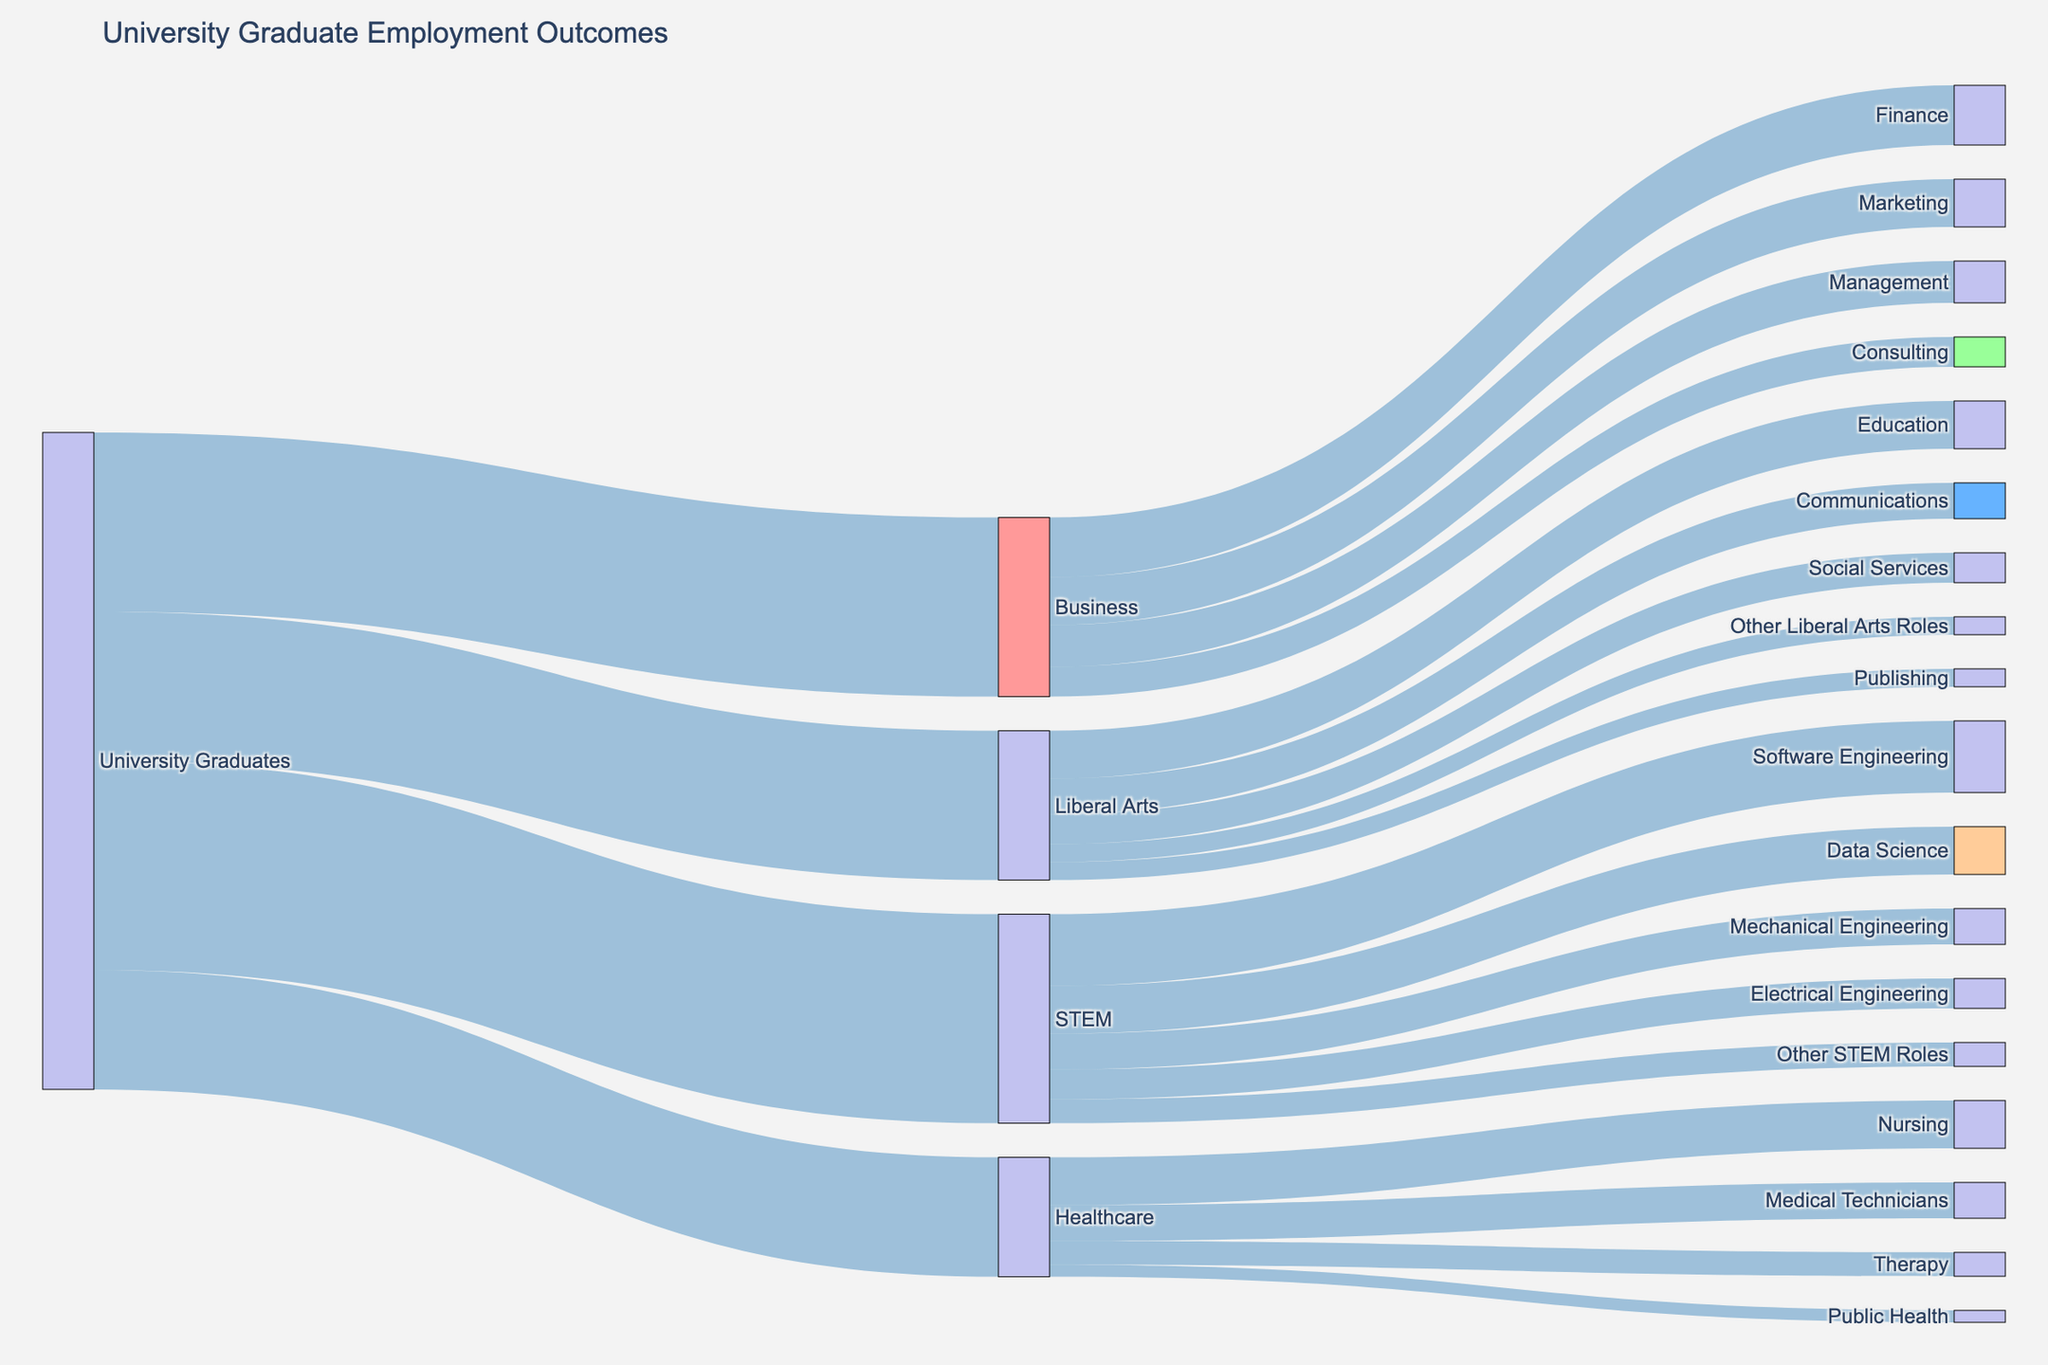What is the title of the figure? The title is typically found at the top of the figure. In this case, it is clearly labeled in the layout settings.
Answer: University Graduate Employment Outcomes What industry do the most University Graduates go into? By observing the height or size of the flows from "University Graduates" to various industries, the largest flow leads to "STEM".
Answer: STEM Which job role in STEM has the highest number of University Graduates? Within the STEM industry, look for the longest (or widest) flow to associated job roles; in this case, it's "Software Engineering".
Answer: Software Engineering How many University Graduates go into healthcare-related jobs? Locate the flows between "Healthcare" and its associated job roles and sum these values: 800 + 600 + 400 + 200 = 2000.
Answer: 2000 Compare the number of University Graduates in STEM versus Business. Which one has more graduates? Compare the values of flows from "University Graduates" to "STEM" and "Business". STEM has 3500, and Business has 3000.
Answer: STEM Which job role has the least number of graduates in Liberal Arts? Within the Liberal Arts industry, observe the smallest flow associated with job roles; here, it's "Publishing" and "Other Liberal Arts Roles" both with 300.
Answer: Publishing, Other Liberal Arts Roles How many more graduates go into Finance compared to Consulting within Business? Identify the values for "Finance" (1000) and "Consulting" (500) under Business and calculate the difference 1000 - 500 = 500.
Answer: 500 What proportion of STEM graduates go into Data Science compared to other STEM roles? Find the value of graduates in "Data Science" (800) and the total of all STEM roles (1200 + 800 + 600 + 500 + 400 = 3500). Then compute the proportion 800 / 3500.
Answer: Approximately 0.23 Which industry has the widest range of job roles? Count the number of unique job roles connected to each industry. STEM has 5 roles, Business has 4 roles, Liberal Arts has 5 roles, and Healthcare has 4 roles.
Answer: STEM and Liberal Arts Are there more graduates in Software Engineering or Nursing? Compare the flows to "Software Engineering" (1200) in STEM and "Nursing" (800) in Healthcare.
Answer: Software Engineering 